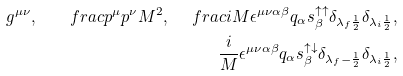Convert formula to latex. <formula><loc_0><loc_0><loc_500><loc_500>g ^ { \mu \nu } , \quad f r a c { p ^ { \mu } p ^ { \nu } } { M ^ { 2 } } , \ \ \ f r a c { i } { M } \epsilon ^ { \mu \nu \alpha \beta } q _ { \alpha } s _ { \beta } ^ { \uparrow \uparrow } \delta _ { \lambda _ { f } \frac { 1 } { 2 } } \delta _ { \lambda _ { i } \frac { 1 } { 2 } } , \\ \frac { i } { M } \epsilon ^ { \mu \nu \alpha \beta } q _ { \alpha } s _ { \beta } ^ { \uparrow \downarrow } \delta _ { \lambda _ { f } - \frac { 1 } { 2 } } \delta _ { \lambda _ { i } \frac { 1 } { 2 } } ,</formula> 